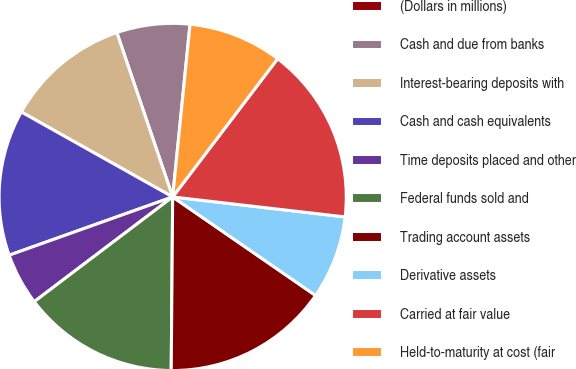Convert chart to OTSL. <chart><loc_0><loc_0><loc_500><loc_500><pie_chart><fcel>(Dollars in millions)<fcel>Cash and due from banks<fcel>Interest-bearing deposits with<fcel>Cash and cash equivalents<fcel>Time deposits placed and other<fcel>Federal funds sold and<fcel>Trading account assets<fcel>Derivative assets<fcel>Carried at fair value<fcel>Held-to-maturity at cost (fair<nl><fcel>0.01%<fcel>6.8%<fcel>11.65%<fcel>13.59%<fcel>4.86%<fcel>14.56%<fcel>15.53%<fcel>7.77%<fcel>16.5%<fcel>8.74%<nl></chart> 